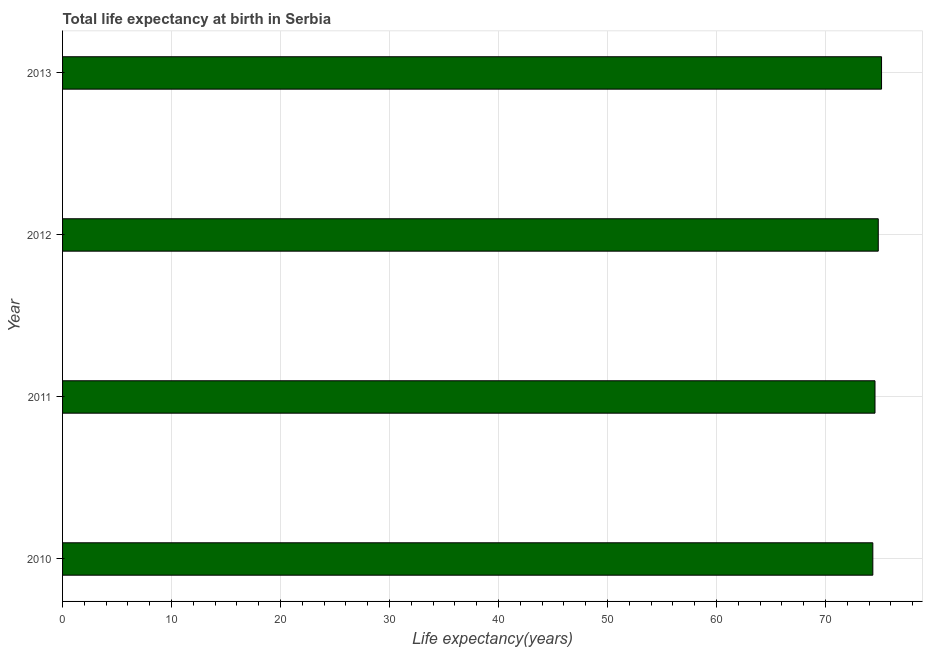Does the graph contain any zero values?
Offer a terse response. No. Does the graph contain grids?
Your response must be concise. Yes. What is the title of the graph?
Offer a terse response. Total life expectancy at birth in Serbia. What is the label or title of the X-axis?
Keep it short and to the point. Life expectancy(years). What is the life expectancy at birth in 2011?
Provide a succinct answer. 74.54. Across all years, what is the maximum life expectancy at birth?
Provide a succinct answer. 75.14. Across all years, what is the minimum life expectancy at birth?
Provide a short and direct response. 74.34. In which year was the life expectancy at birth maximum?
Provide a short and direct response. 2013. What is the sum of the life expectancy at birth?
Offer a very short reply. 298.85. What is the average life expectancy at birth per year?
Provide a short and direct response. 74.71. What is the median life expectancy at birth?
Give a very brief answer. 74.69. In how many years, is the life expectancy at birth greater than 8 years?
Make the answer very short. 4. Do a majority of the years between 2011 and 2012 (inclusive) have life expectancy at birth greater than 34 years?
Ensure brevity in your answer.  Yes. What is the difference between the highest and the lowest life expectancy at birth?
Make the answer very short. 0.8. In how many years, is the life expectancy at birth greater than the average life expectancy at birth taken over all years?
Keep it short and to the point. 2. How many bars are there?
Your answer should be very brief. 4. How many years are there in the graph?
Offer a terse response. 4. What is the difference between two consecutive major ticks on the X-axis?
Provide a short and direct response. 10. Are the values on the major ticks of X-axis written in scientific E-notation?
Your response must be concise. No. What is the Life expectancy(years) of 2010?
Your response must be concise. 74.34. What is the Life expectancy(years) in 2011?
Offer a terse response. 74.54. What is the Life expectancy(years) of 2012?
Ensure brevity in your answer.  74.84. What is the Life expectancy(years) in 2013?
Provide a short and direct response. 75.14. What is the difference between the Life expectancy(years) in 2010 and 2012?
Offer a terse response. -0.5. What is the difference between the Life expectancy(years) in 2011 and 2012?
Make the answer very short. -0.3. What is the difference between the Life expectancy(years) in 2011 and 2013?
Provide a short and direct response. -0.6. What is the difference between the Life expectancy(years) in 2012 and 2013?
Make the answer very short. -0.3. What is the ratio of the Life expectancy(years) in 2010 to that in 2013?
Offer a very short reply. 0.99. What is the ratio of the Life expectancy(years) in 2011 to that in 2012?
Ensure brevity in your answer.  1. What is the ratio of the Life expectancy(years) in 2011 to that in 2013?
Your answer should be very brief. 0.99. 